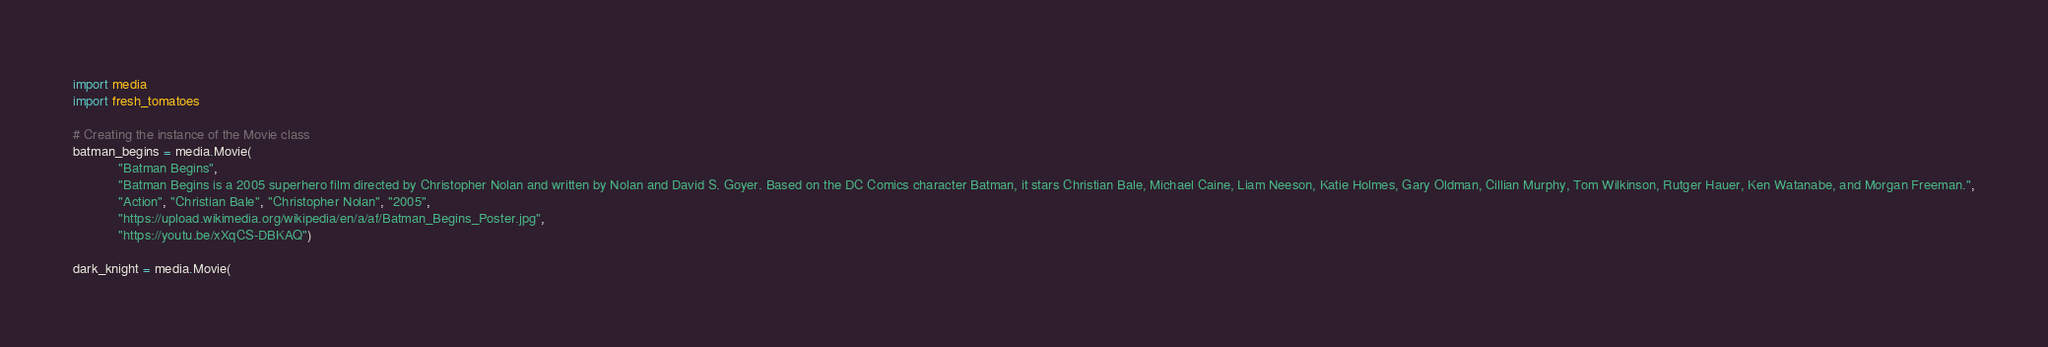<code> <loc_0><loc_0><loc_500><loc_500><_Python_>import media
import fresh_tomatoes

# Creating the instance of the Movie class
batman_begins = media.Movie(
            "Batman Begins",
            "Batman Begins is a 2005 superhero film directed by Christopher Nolan and written by Nolan and David S. Goyer. Based on the DC Comics character Batman, it stars Christian Bale, Michael Caine, Liam Neeson, Katie Holmes, Gary Oldman, Cillian Murphy, Tom Wilkinson, Rutger Hauer, Ken Watanabe, and Morgan Freeman.",
            "Action", "Christian Bale", "Christopher Nolan", "2005",
            "https://upload.wikimedia.org/wikipedia/en/a/af/Batman_Begins_Poster.jpg",
            "https://youtu.be/xXqCS-DBKAQ") 

dark_knight = media.Movie(</code> 